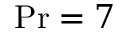<formula> <loc_0><loc_0><loc_500><loc_500>P r = 7</formula> 